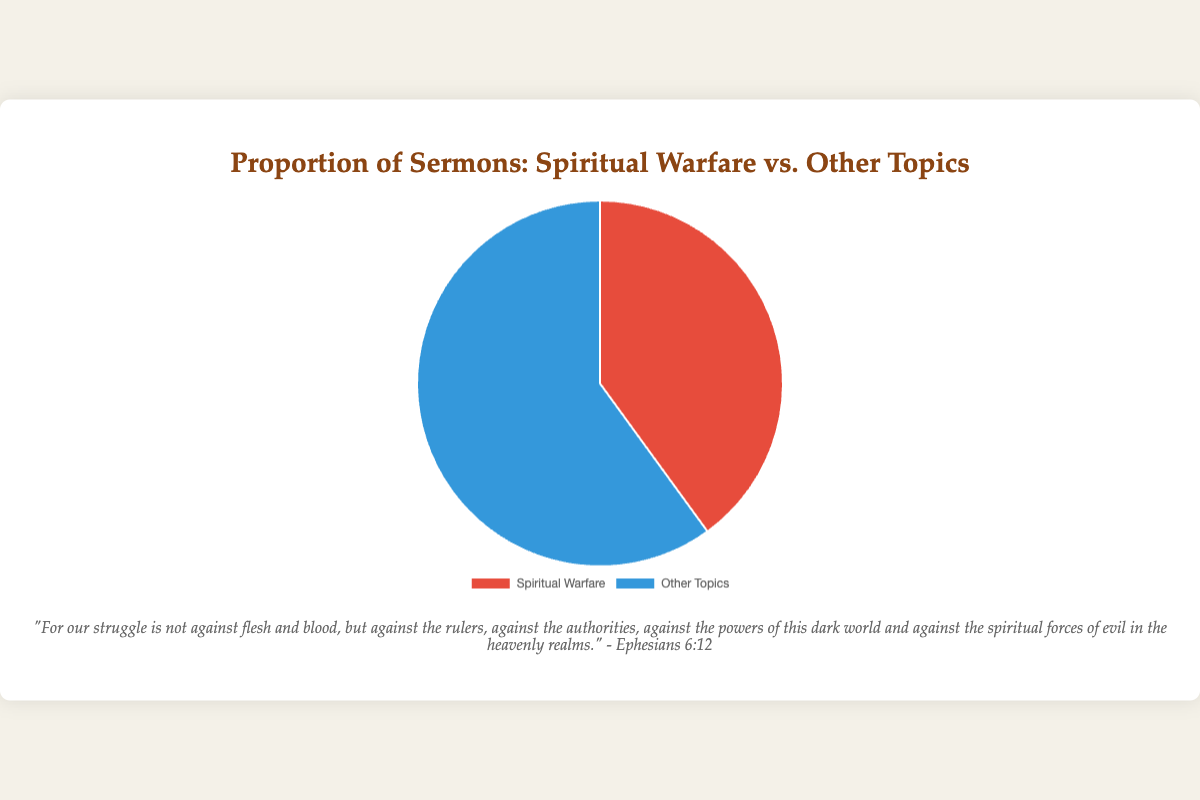What proportion of sermons focus on Spiritual Warfare? The pie chart shows the proportions of different sermon topics, with "Spiritual Warfare" colored red and labeled as making up 40% of the chart.
Answer: 40% What proportion of sermons focus on topics other than Spiritual Warfare? The pie chart indicates that sermons on "Other Topics" are colored blue and account for 60% of the chart.
Answer: 60% How much larger is the proportion of sermons on Other Topics compared to Spiritual Warfare? The proportion of sermons on Other Topics is 60%, while Spiritual Warfare is 40%. The difference is 60% - 40% = 20%.
Answer: 20% What is the ratio of sermons on Spiritual Warfare to sermons on Other Topics? The proportion of sermons on Spiritual Warfare is 40%, and on Other Topics is 60%. The ratio is 40:60, which simplifies to 2:3.
Answer: 2:3 If there were 100 sermons delivered, how many of them would focus on Spiritual Warfare? As 40% of the sermons focus on Spiritual Warfare, for 100 sermons, it would be 40% of 100, which is (40/100) * 100 = 40 sermons.
Answer: 40 What color is used to represent sermons on Other Topics? The pie chart uses blue to represent the portion of sermons focused on Other Topics.
Answer: Blue Are there more sermons on Spiritual Warfare or Other Topics? The pie chart shows that 60% of sermons are on Other Topics compared to 40% on Spiritual Warfare, indicating there are more sermons on Other Topics.
Answer: Other Topics If the chart shows 200 sermons, how many would be on topics other than Spiritual Warfare? For 200 sermons, 60% of them focus on Other Topics. Thus, (60/100) * 200 = 120 sermons would be on Other Topics.
Answer: 120 